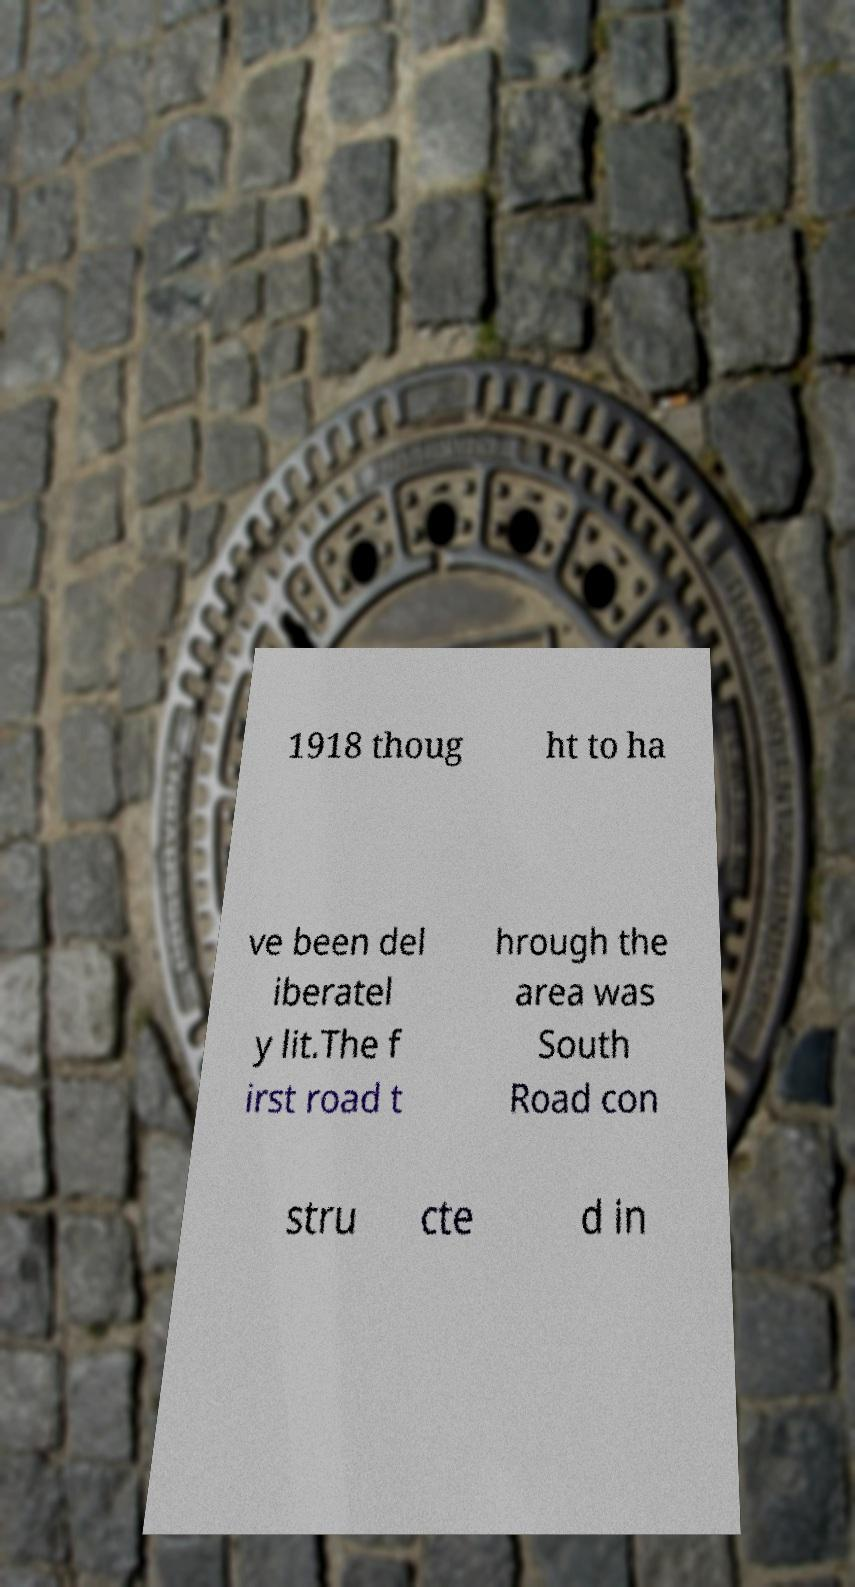What messages or text are displayed in this image? I need them in a readable, typed format. 1918 thoug ht to ha ve been del iberatel y lit.The f irst road t hrough the area was South Road con stru cte d in 